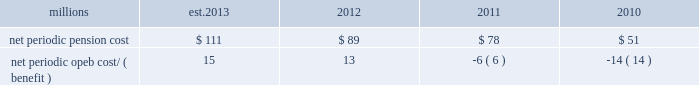The table presents the net periodic pension and opeb cost/ ( benefit ) for the years ended december 31 : millions 2013 2012 2011 2010 .
Our net periodic pension cost is expected to increase to approximately $ 111 million in 2013 from $ 89 million in 2012 .
The increase is driven mainly by a decrease in the discount rate to 3.78% ( 3.78 % ) , our net periodic opeb expense is expected to increase to approximately $ 15 million in 2013 from $ 13 million in 2012 .
The increase in our net periodic opeb cost is primarily driven by a decrease in the discount rate to 3.48% ( 3.48 % ) .
Cautionary information certain statements in this report , and statements in other reports or information filed or to be filed with the sec ( as well as information included in oral statements or other written statements made or to be made by us ) , are , or will be , forward-looking statements as defined by the securities act of 1933 and the securities exchange act of 1934 .
These forward-looking statements and information include , without limitation , ( a ) statements in the ceo 2019s letter preceding part i ; statements regarding planned capital expenditures under the caption 201c2013 capital expenditures 201d in item 2 of part i ; statements regarding dividends in item 5 ; and statements and information set forth under the captions 201c2013 outlook 201d and 201cliquidity and capital resources 201d in this item 7 , and ( b ) any other statements or information in this report ( including information incorporated herein by reference ) regarding : expectations as to financial performance , revenue growth and cost savings ; the time by which goals , targets , or objectives will be achieved ; projections , predictions , expectations , estimates , or forecasts as to our business , financial and operational results , future economic performance , and general economic conditions ; expectations as to operational or service performance or improvements ; expectations as to the effectiveness of steps taken or to be taken to improve operations and/or service , including capital expenditures for infrastructure improvements and equipment acquisitions , any strategic business acquisitions , and modifications to our transportation plans ( including statements set forth in item 2 as to expectations related to our planned capital expenditures ) ; expectations as to existing or proposed new products and services ; expectations as to the impact of any new regulatory activities or legislation on our operations or financial results ; estimates of costs relating to environmental remediation and restoration ; estimates and expectations regarding tax matters ; expectations that claims , litigation , environmental costs , commitments , contingent liabilities , labor negotiations or agreements , or other matters will not have a material adverse effect on our consolidated results of operations , financial condition , or liquidity and any other similar expressions concerning matters that are not historical facts .
Forward-looking statements may be identified by their use of forward-looking terminology , such as 201cbelieves , 201d 201cexpects , 201d 201cmay , 201d 201cshould , 201d 201cwould , 201d 201cwill , 201d 201cintends , 201d 201cplans , 201d 201cestimates , 201d 201canticipates , 201d 201cprojects 201d and similar words , phrases or expressions .
Forward-looking statements should not be read as a guarantee of future performance or results , and will not necessarily be accurate indications of the times that , or by which , such performance or results will be achieved .
Forward-looking statements and information are subject to risks and uncertainties that could cause actual performance or results to differ materially from those expressed in the statements and information .
Forward-looking statements and information reflect the good faith consideration by management of currently available information , and may be based on underlying assumptions believed to be reasonable under the circumstances .
However , such information and assumptions ( and , therefore , such forward-looking statements and information ) are or may be subject to variables or unknown or unforeseeable events or circumstances over which management has little or no influence or control .
The risk factors in item 1a of this report could affect our future results and could cause those results or other outcomes to differ materially from those expressed or implied in any forward-looking statements or information .
To the extent circumstances require or we deem it otherwise necessary , we will update or amend these risk factors in a form 10-q , form 8-k or subsequent form 10-k .
All forward-looking statements are qualified by , and should be read in conjunction with , these risk factors .
Forward-looking statements speak only as of the date the statement was made .
We assume no obligation to update forward-looking information to reflect actual results , changes in assumptions or changes in other factors affecting forward-looking information .
If we do update one or more forward-looking .
What is the estimated growth rate in net periodic pension cost from 2012 to 2013? 
Computations: ((111 - 89) / 89)
Answer: 0.24719. 